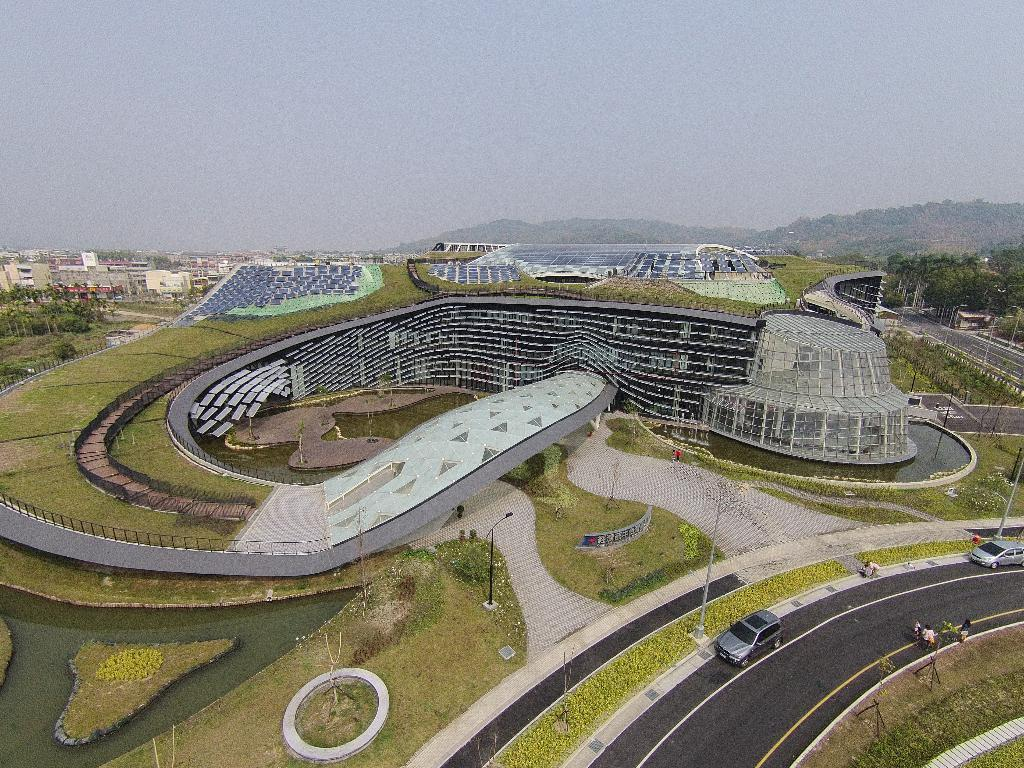What color is the sky in the image? The sky is blue in the image. What can be seen on the road in the image? There are vehicles on the road in the image. What type of structures are visible in the image? There are buildings visible in the image. What type of vegetation is present in the image? There are trees present in the image. What scientific discovery was made during the summer in the image? There is no scientific discovery or reference to summer in the image; it simply depicts a blue sky, vehicles on the road, buildings, and trees. 